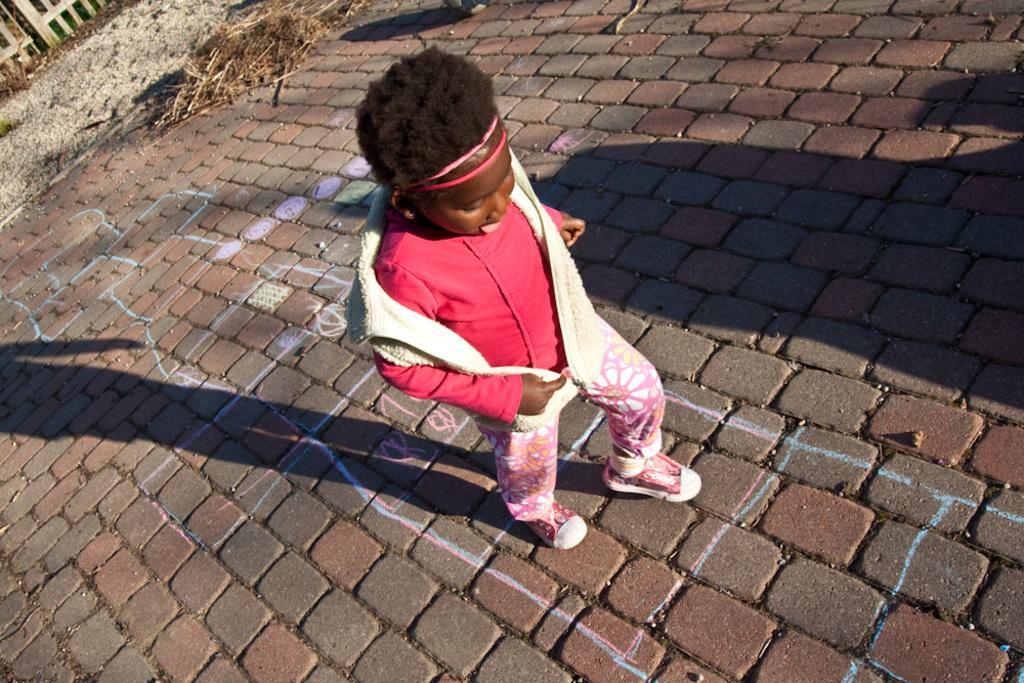Can you describe this image briefly? In this image the person playing on the ground. At the back there is a grass , sand and fence with bricks. 